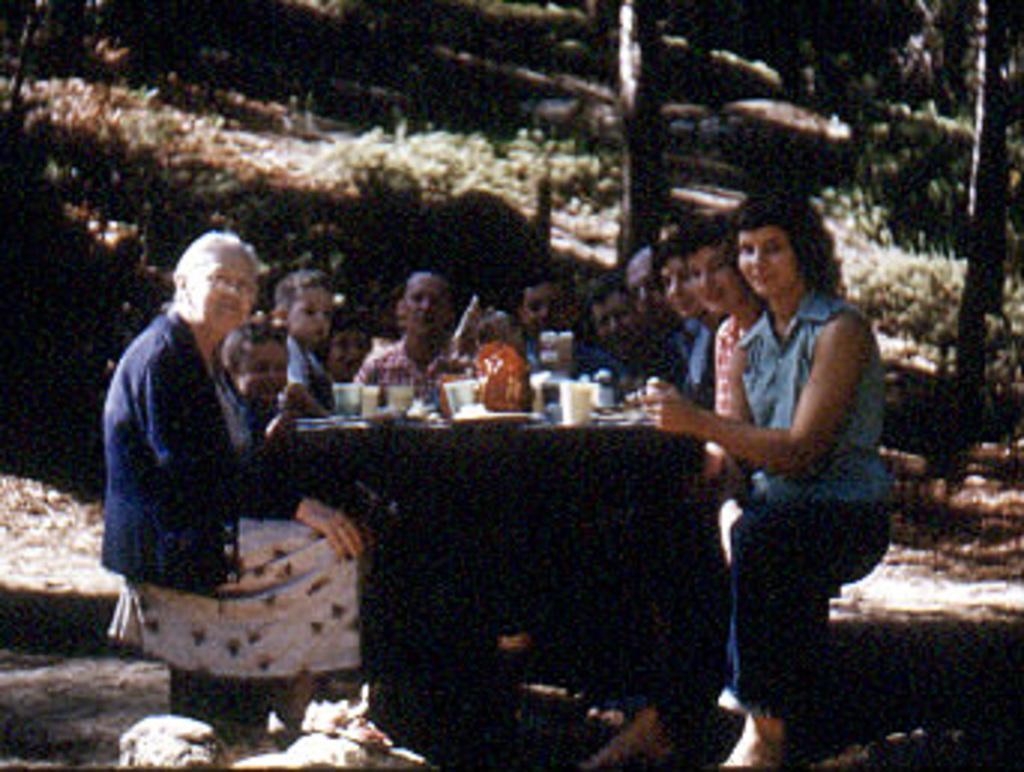Describe this image in one or two sentences. In the image we can see there are people sitting and they are wearing clothes. Here we can see the table, on the table, we can see glasses and other things. Here we can see stones, grass and the image is slightly blurred. 